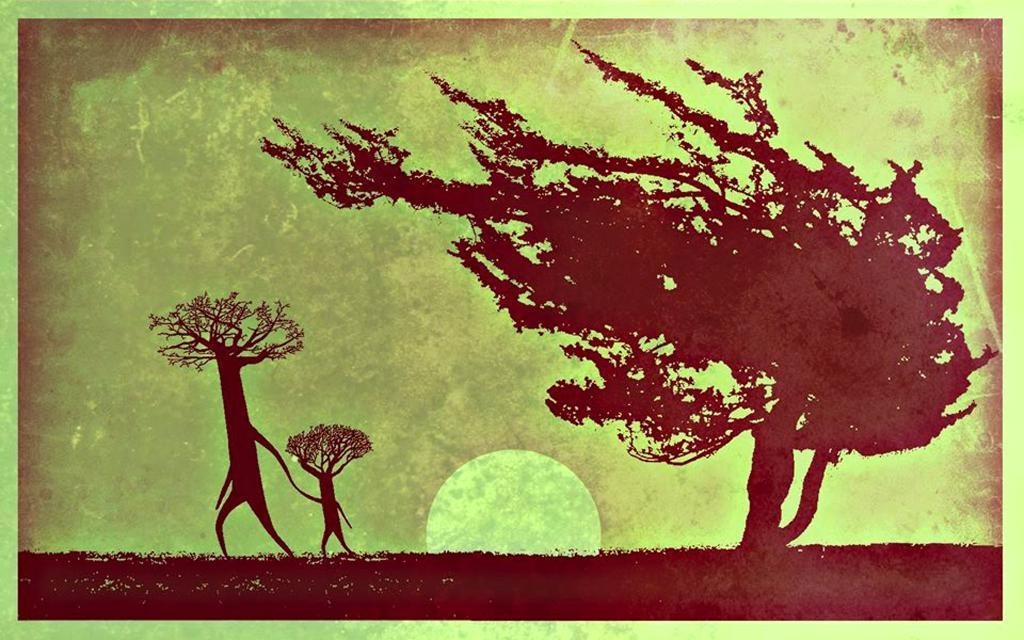What type of natural elements can be seen in the image? There are trees in the image. What celestial body is visible in the background of the image? There is a moon visible in the background of the image. How can we classify the image based on its appearance? The image appears to be a painting. What type of ladybug can be seen crawling on the moon in the image? There is no ladybug present in the image; it only features trees and a moon in the background. What is the aftermath of the event depicted in the image? The image does not depict an event, so there is no aftermath to discuss. 